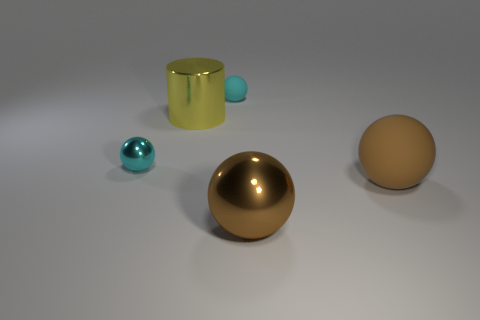There is another object that is the same color as the big matte object; what is it made of?
Your response must be concise. Metal. What is the size of the other sphere that is the same color as the small matte sphere?
Your answer should be very brief. Small. Is there any other thing that is made of the same material as the big yellow thing?
Make the answer very short. Yes. Are there fewer balls right of the cylinder than large yellow cylinders in front of the large brown shiny thing?
Your answer should be very brief. No. Is there anything else that has the same color as the big matte thing?
Offer a very short reply. Yes. What shape is the brown rubber thing?
Make the answer very short. Sphere. There is a big sphere that is the same material as the yellow cylinder; what is its color?
Your response must be concise. Brown. Is the number of brown rubber spheres greater than the number of big gray metallic blocks?
Provide a short and direct response. Yes. Are any small cyan objects visible?
Give a very brief answer. Yes. The large metallic object that is behind the big metal object that is in front of the brown matte sphere is what shape?
Your answer should be compact. Cylinder. 